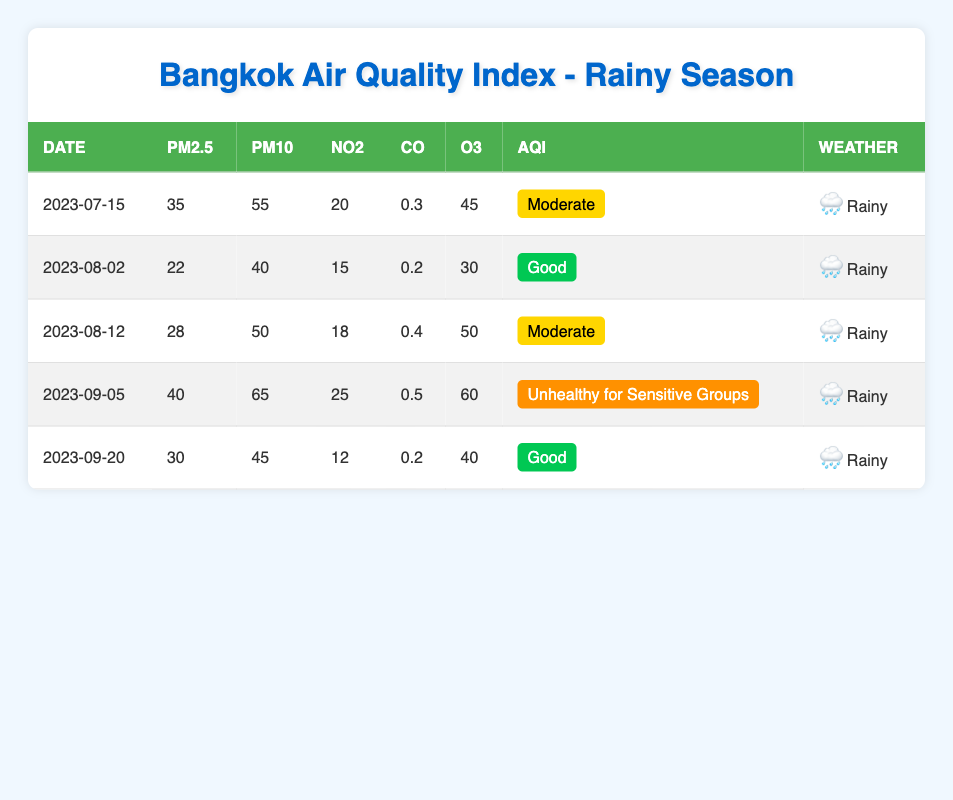What is the air quality index (AQI) for the date 2023-08-02? In the row corresponding to the date 2023-08-02, I can see that the AQI listed is "Good".
Answer: Good What was the PM2.5 level on 2023-09-05? Looking at the row for 2023-09-05, the PM2.5 level recorded is 40.
Answer: 40 Was the air quality on 2023-08-12 considered unhealthy? By checking the AQI for 2023-08-12, which is "Moderate", it indicates the air quality was not unhealthy.
Answer: No What is the average NO2 level across all entries in the table? To find the average NO2 level, I need to sum up the NO2 values (20 + 15 + 18 + 25 + 12 = 90) and divide by the number of days (5), resulting in an average of 90/5 = 18.
Answer: 18 On which date did the air quality read as "Unhealthy for Sensitive Groups"? In the table, the AQI for 2023-09-05 is listed as "Unhealthy for Sensitive Groups", indicating that this is the date.
Answer: 2023-09-05 What was the CO level on 2023-08-02 and how does it compare to 2023-09-20? The CO level on 2023-08-02 is 0.2, while on 2023-09-20, it is 0.2 as well. Since both values are equal, it can be said that they are the same.
Answer: Equal How many readings in the table show a PM10 level above 50? Looking through the PM10 values provided, I see that there are two readings (55 on 2023-07-15 and 65 on 2023-09-05) that are above 50.
Answer: 2 What were the weather conditions on 2023-09-05? The table shows that the weather condition for 2023-09-05 is labeled as "Rainy".
Answer: Rainy Which date had the highest PM2.5 reading and what was the value? Checking the table, 2023-09-05 has the highest PM2.5 reading of 40.
Answer: 2023-09-05, 40 